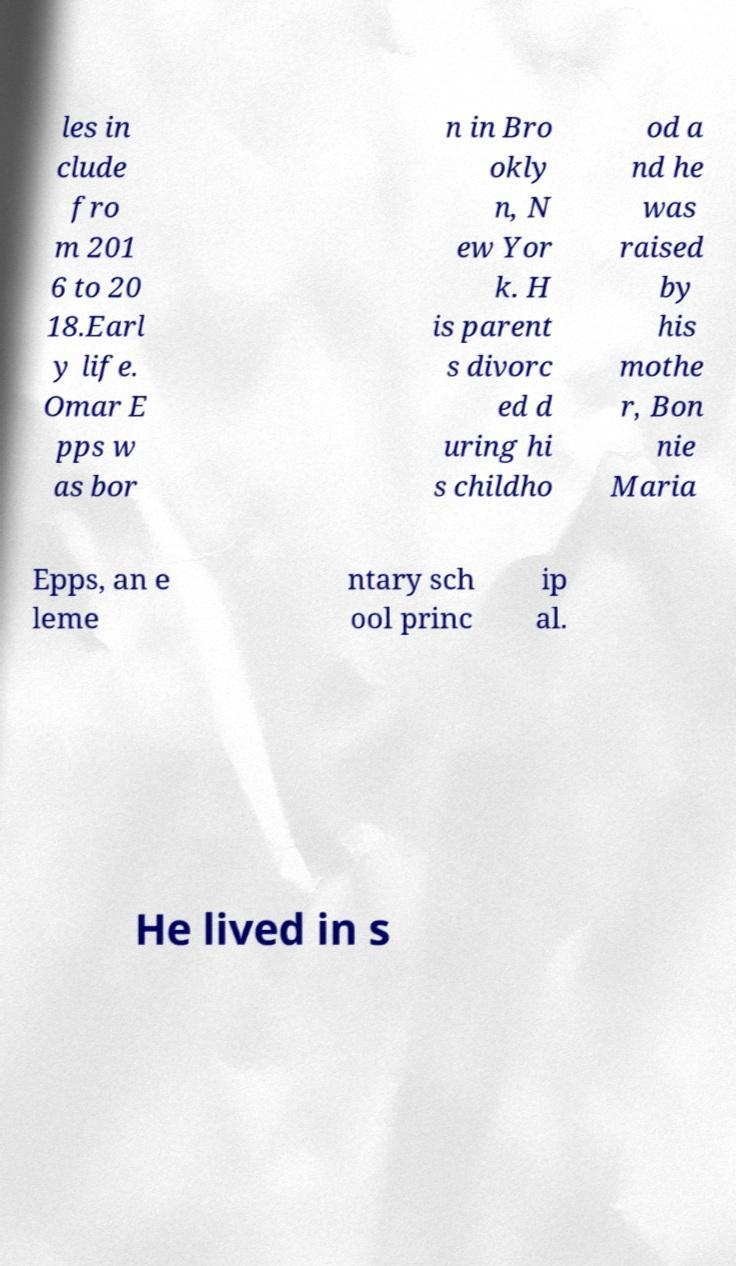Can you read and provide the text displayed in the image?This photo seems to have some interesting text. Can you extract and type it out for me? les in clude fro m 201 6 to 20 18.Earl y life. Omar E pps w as bor n in Bro okly n, N ew Yor k. H is parent s divorc ed d uring hi s childho od a nd he was raised by his mothe r, Bon nie Maria Epps, an e leme ntary sch ool princ ip al. He lived in s 